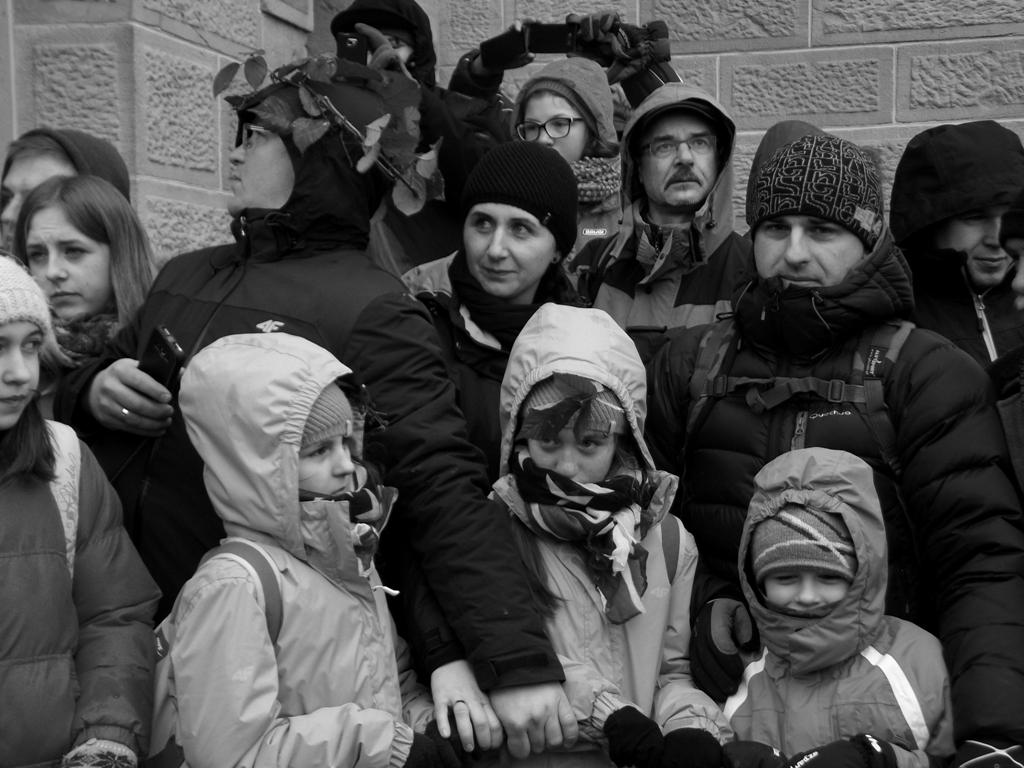How many people are in the image? There is a group of people in the image. What is the background of the image? The group of people is standing in front of a wall. Can you describe any objects that one of the people is holding? One person is holding a cellphone. What are some people holding in addition to the cellphone? Some people are holding a rope. What time is it in the image? The image does not provide any information about the time. Can you see any cars in the image? There are no cars visible in the image. 